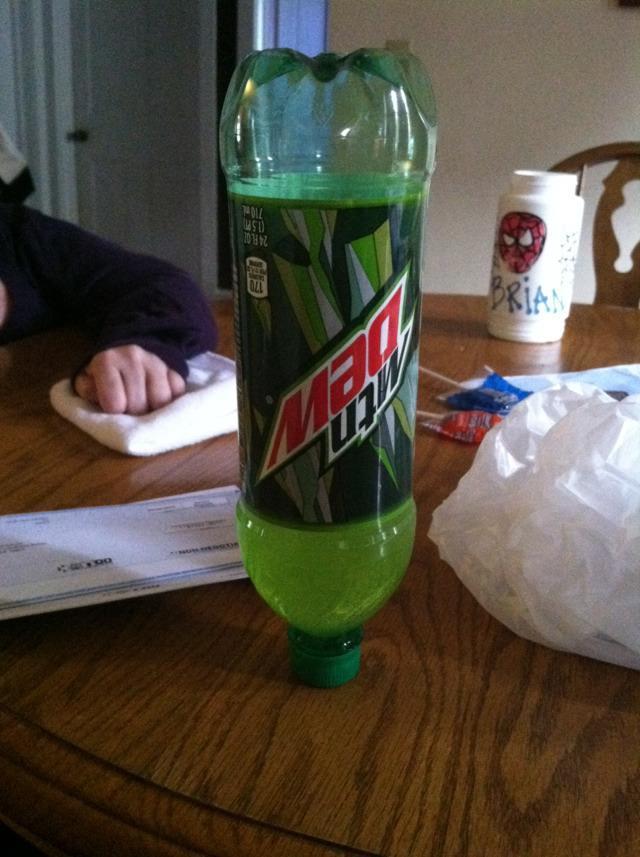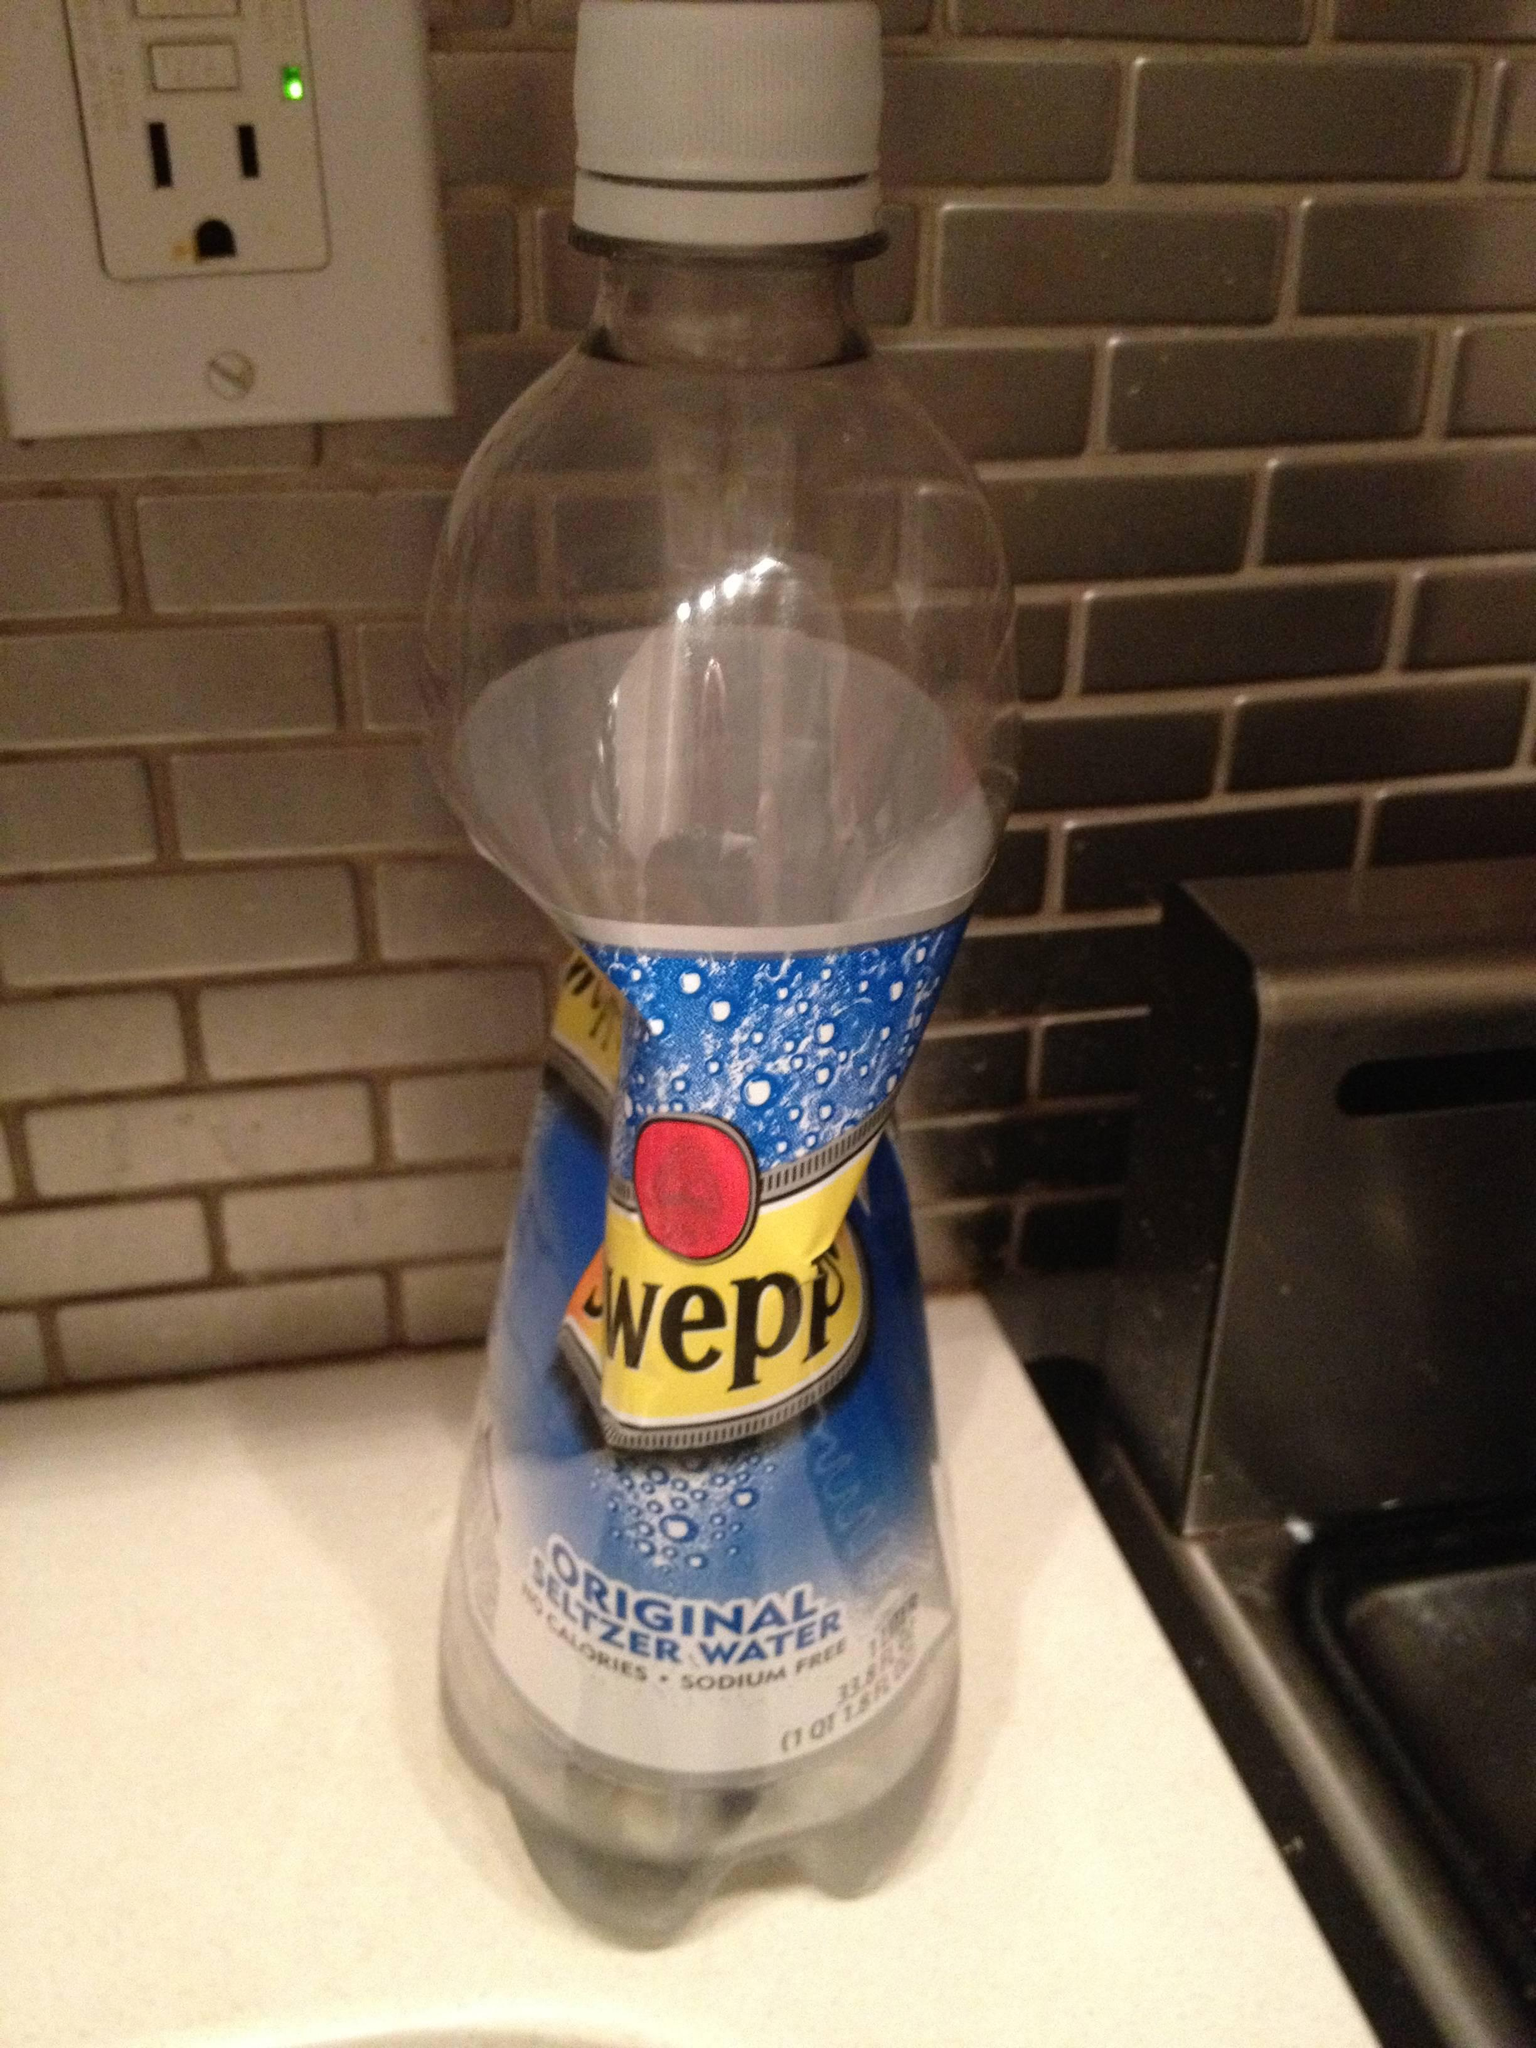The first image is the image on the left, the second image is the image on the right. Considering the images on both sides, is "There is at least one  twisted  or crushed soda bottle" valid? Answer yes or no. Yes. The first image is the image on the left, the second image is the image on the right. Assess this claim about the two images: "There are at least two hands.". Correct or not? Answer yes or no. No. 